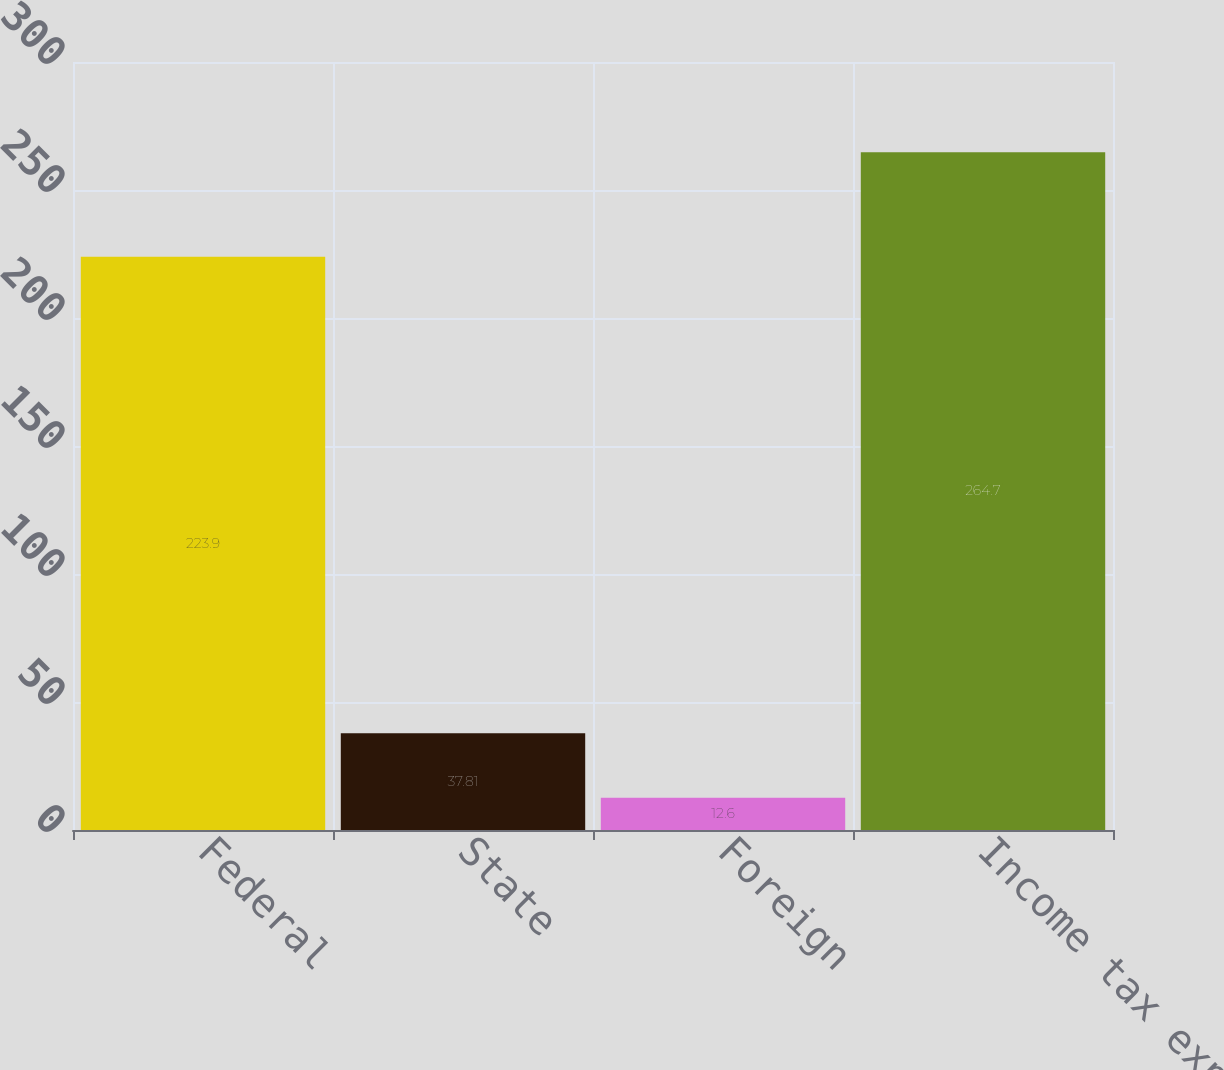Convert chart. <chart><loc_0><loc_0><loc_500><loc_500><bar_chart><fcel>Federal<fcel>State<fcel>Foreign<fcel>Income tax expense<nl><fcel>223.9<fcel>37.81<fcel>12.6<fcel>264.7<nl></chart> 